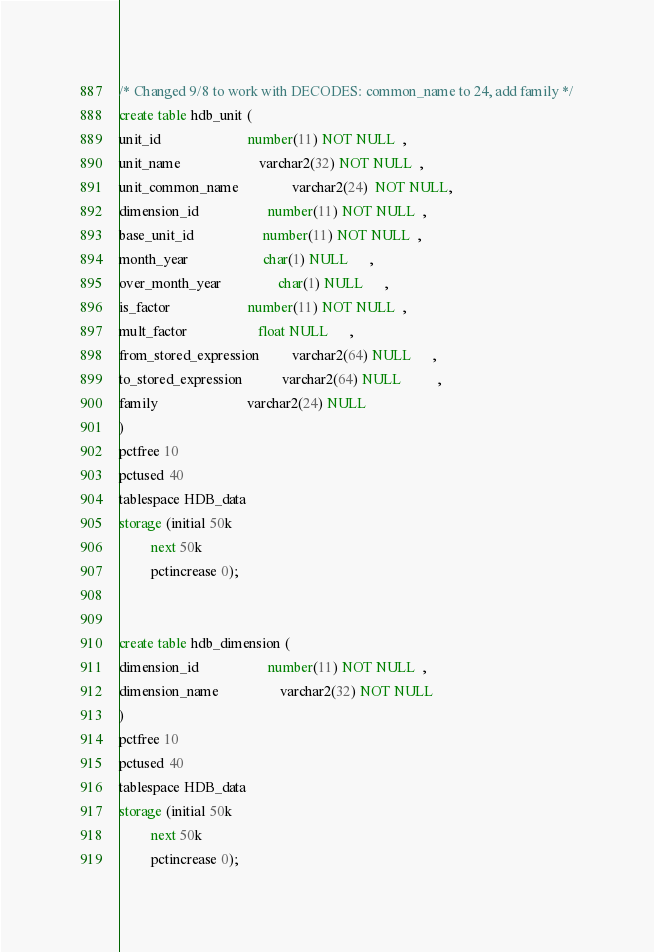<code> <loc_0><loc_0><loc_500><loc_500><_SQL_>
/* Changed 9/8 to work with DECODES: common_name to 24, add family */
create table hdb_unit (                              
unit_id                        number(11) NOT NULL  ,   
unit_name                      varchar2(32) NOT NULL  ,  
unit_common_name               varchar2(24)  NOT NULL, 
dimension_id                   number(11) NOT NULL  ,    
base_unit_id                   number(11) NOT NULL  ,   
month_year                     char(1) NULL      ,     
over_month_year                char(1) NULL      ,    
is_factor                      number(11) NOT NULL  ,
mult_factor                    float NULL      ,    
from_stored_expression         varchar2(64) NULL      ,    
to_stored_expression           varchar2(64) NULL          ,
family                         varchar2(24) NULL
)                                                        
pctfree 10
pctused 40
tablespace HDB_data
storage (initial 50k
         next 50k
         pctincrease 0);


create table hdb_dimension (              
dimension_id                   number(11) NOT NULL  ,    
dimension_name                 varchar2(32) NOT NULL    
)                                                      
pctfree 10
pctused 40
tablespace HDB_data
storage (initial 50k
         next 50k
         pctincrease 0);

</code> 